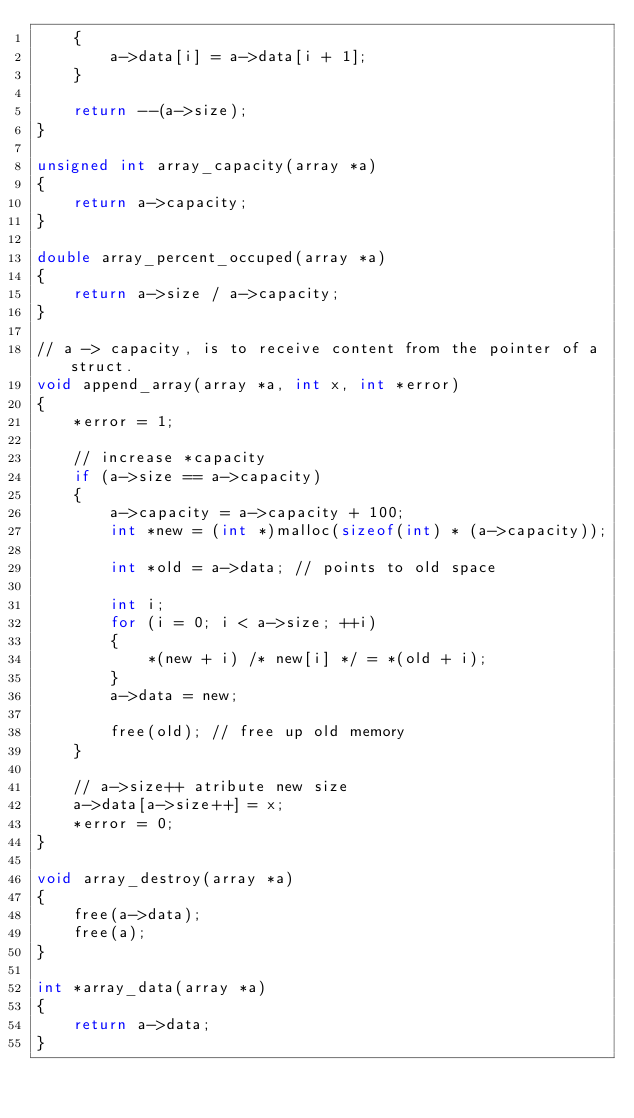<code> <loc_0><loc_0><loc_500><loc_500><_C_>    {
        a->data[i] = a->data[i + 1];
    }

    return --(a->size);
}

unsigned int array_capacity(array *a)
{
    return a->capacity;
}

double array_percent_occuped(array *a)
{
    return a->size / a->capacity;
}

// a -> capacity, is to receive content from the pointer of a struct.
void append_array(array *a, int x, int *error)
{
    *error = 1;

    // increase *capacity
    if (a->size == a->capacity)
    {
        a->capacity = a->capacity + 100;
        int *new = (int *)malloc(sizeof(int) * (a->capacity));

        int *old = a->data; // points to old space

        int i;
        for (i = 0; i < a->size; ++i)
        {
            *(new + i) /* new[i] */ = *(old + i);
        }
        a->data = new;

        free(old); // free up old memory
    }

    // a->size++ atribute new size
    a->data[a->size++] = x;
    *error = 0;
}

void array_destroy(array *a)
{
    free(a->data);
    free(a);
}

int *array_data(array *a)
{
    return a->data;
}
</code> 